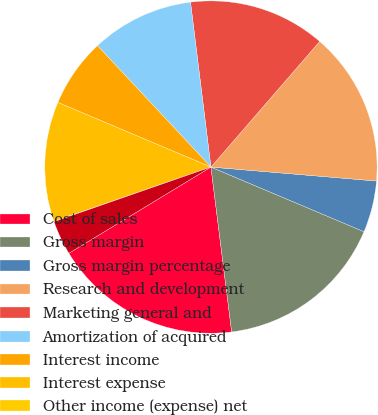Convert chart. <chart><loc_0><loc_0><loc_500><loc_500><pie_chart><fcel>Cost of sales<fcel>Gross margin<fcel>Gross margin percentage<fcel>Research and development<fcel>Marketing general and<fcel>Amortization of acquired<fcel>Interest income<fcel>Interest expense<fcel>Other income (expense) net<fcel>Minority interest in<nl><fcel>18.31%<fcel>16.65%<fcel>5.02%<fcel>14.98%<fcel>13.32%<fcel>10.0%<fcel>6.68%<fcel>11.66%<fcel>0.03%<fcel>3.35%<nl></chart> 